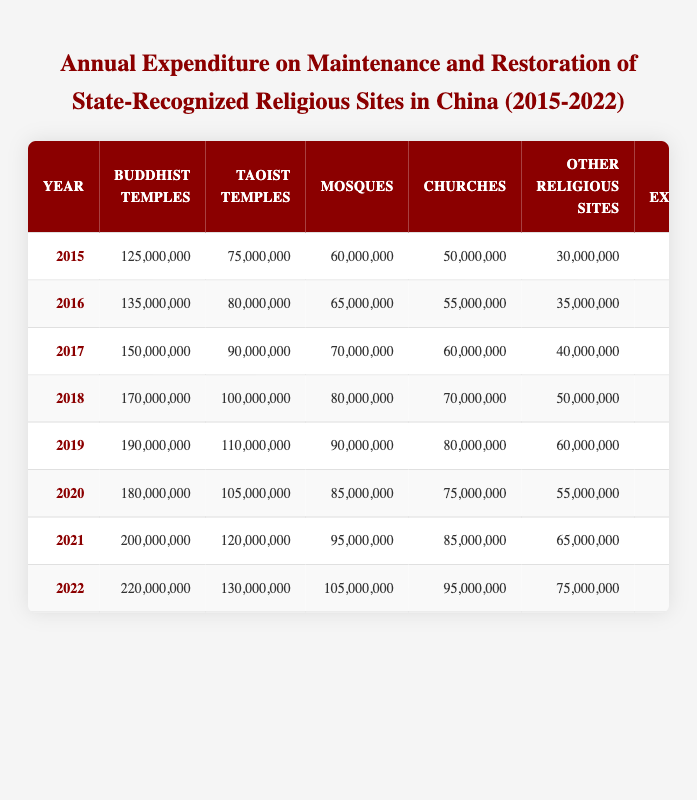What was the total expenditure on Buddhist temples in 2019? According to the table, the expenditure on Buddhist temples for the year 2019 is listed as 190,000,000.
Answer: 190,000,000 What was the total expenditure in 2020 and how does it compare to 2019? The table states that the total expenditure for 2020 is 500,000,000 and for 2019 it was 530,000,000. Comparing these two values, 500,000,000 is 30,000,000 less than 530,000,000.
Answer: 500,000,000; it is less by 30,000,000 Which year had the highest expenditure on maintenance and restoration of all religious sites? The total expenditures for all years are: 340,000,000 (2015), 370,000,000 (2016), 410,000,000 (2017), 470,000,000 (2018), 530,000,000 (2019), 500,000,000 (2020), 565,000,000 (2021), and 625,000,000 (2022). The highest value is 625,000,000 for the year 2022.
Answer: 2022 Is the expenditure on Taoist temples higher in 2021 than in 2018? The table shows expenditure on Taoist temples as 120,000,000 in 2021 and 100,000,000 in 2018. Since 120,000,000 is greater than 100,000,000, the expenditure in 2021 is indeed higher.
Answer: Yes What is the average expenditure on mosques from 2015 to 2022? The expenditure on mosques for the years is: 60,000,000 (2015), 65,000,000 (2016), 70,000,000 (2017), 80,000,000 (2018), 90,000,000 (2019), 85,000,000 (2020), 95,000,000 (2021), and 105,000,000 (2022). Adding these values gives a total of 750,000,000. To find the average, divide by the number of years, which is 8. Therefore, 750,000,000 / 8 = 93,750,000.
Answer: 93,750,000 Overall, how much more was spent on Buddhist temples in 2022 compared to 2015? The expenditure on Buddhist temples in 2022 is 220,000,000, while in 2015 it was 125,000,000. The difference is calculated by subtracting: 220,000,000 - 125,000,000 = 95,000,000.
Answer: 95,000,000 Did spending on churches increase every year from 2015 to 2022? The expenditures on churches from 2015 to 2022 were: 50,000,000 (2015), 55,000,000 (2016), 60,000,000 (2017), 70,000,000 (2018), 80,000,000 (2019), 75,000,000 (2020), 85,000,000 (2021), and 95,000,000 (2022). Notably, the expenditure decreased from 80,000,000 in 2019 to 75,000,000 in 2020. Since there was a decrease, we can conclude it did not increase every year.
Answer: No 